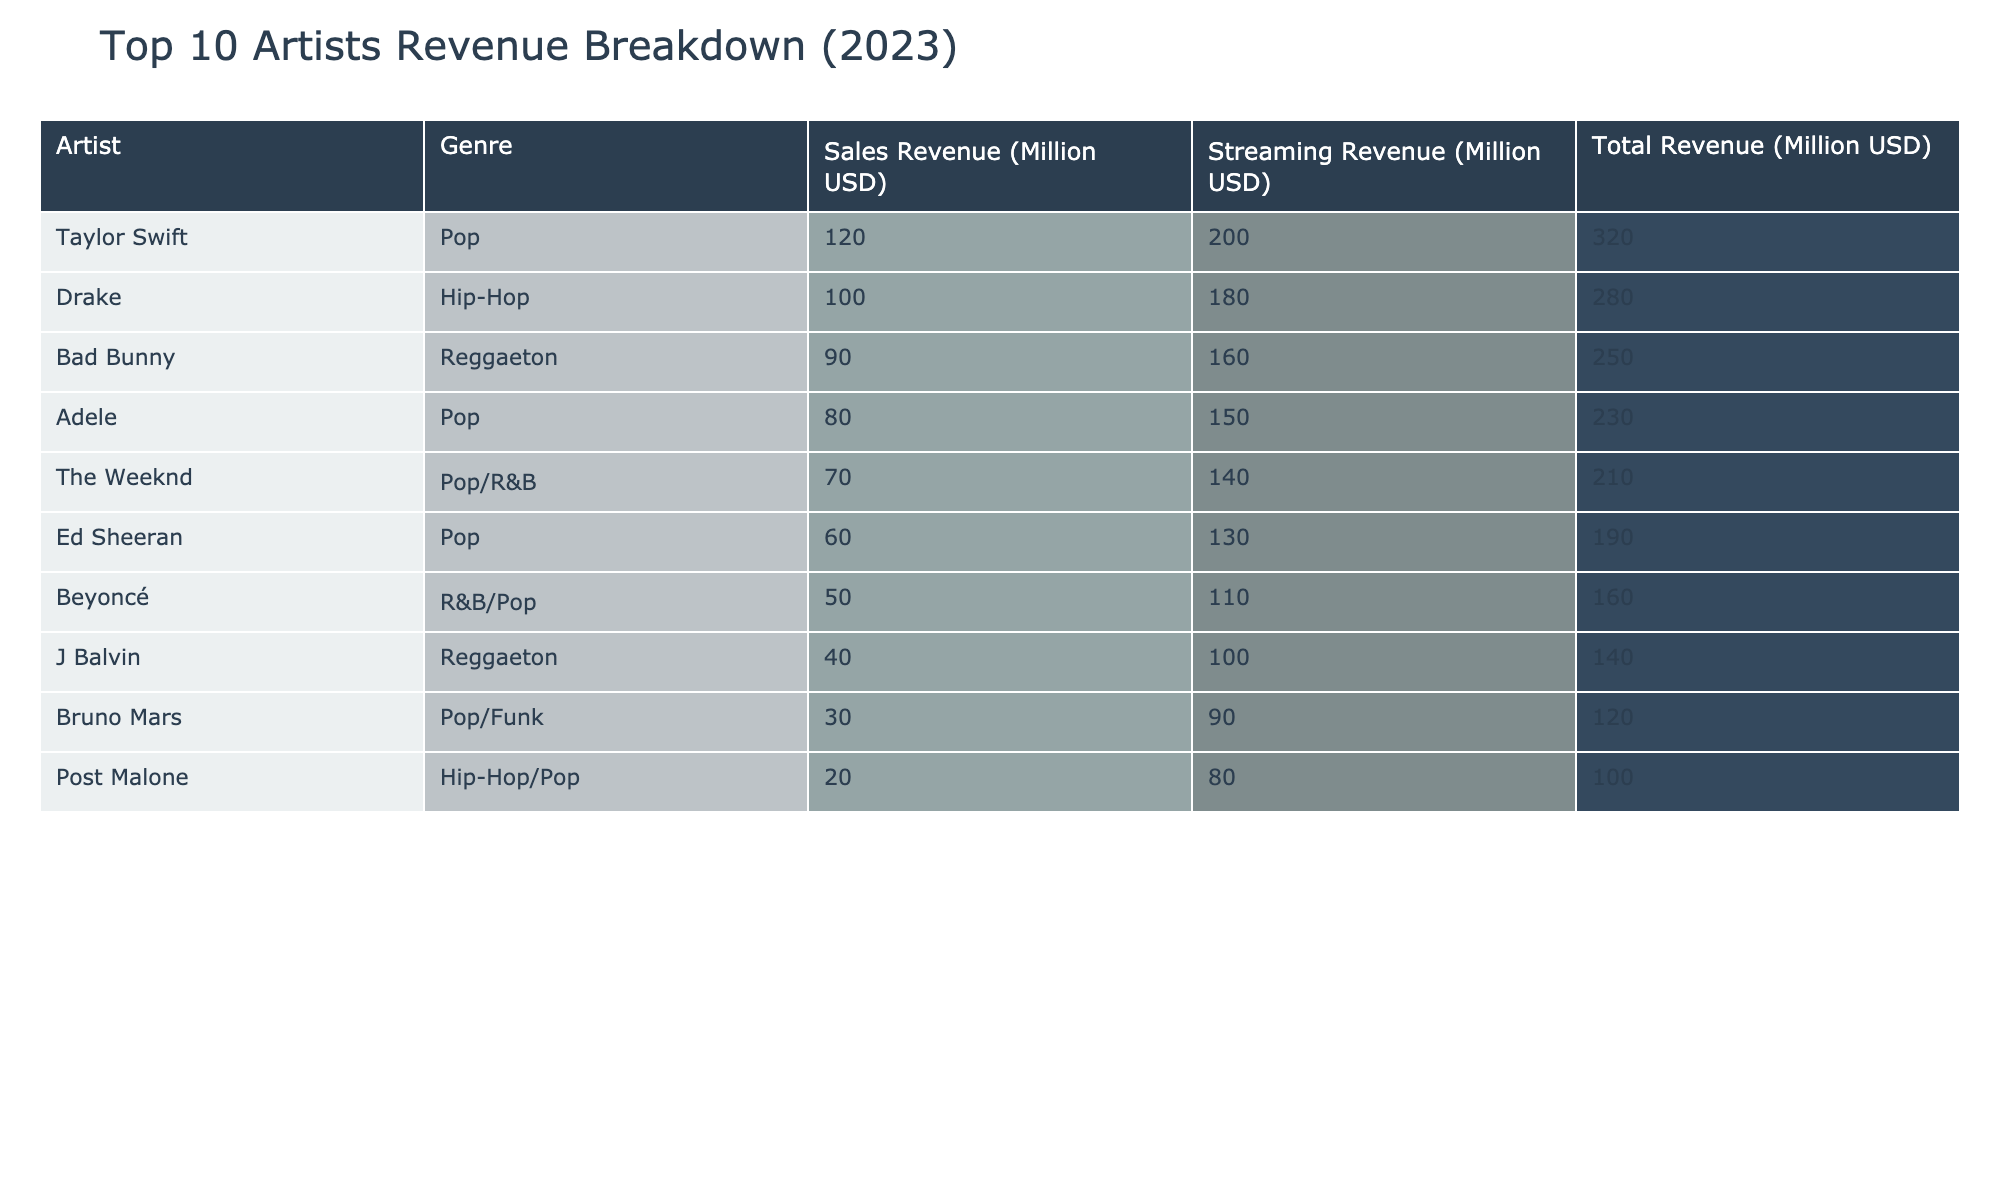What is the total revenue generated by Taylor Swift in 2023? Taylor Swift's total revenue is listed directly in the table as 320 million USD.
Answer: 320 million USD Which artist has the highest streaming revenue? The table indicates that Taylor Swift has the highest streaming revenue at 200 million USD.
Answer: Taylor Swift What is the sales revenue of Adele? The sales revenue for Adele is explicitly shown in the table as 80 million USD.
Answer: 80 million USD How much more streaming revenue does Drake have compared to Bruno Mars? Drake's streaming revenue is 180 million USD, while Bruno Mars has 90 million USD. The difference is 180 - 90 = 90 million USD.
Answer: 90 million USD What is the total revenue for the bottom two artists, Post Malone and Bruno Mars? Post Malone has a total revenue of 100 million USD and Bruno Mars has 120 million USD. Adding these gives 100 + 120 = 220 million USD.
Answer: 220 million USD What percentage of total revenue for Bad Bunny comes from sales revenue? Bad Bunny's total revenue is 250 million USD with 90 million USD from sales. The percentage is (90 / 250) * 100 = 36%.
Answer: 36% Which genre has the highest average sales revenue among the artists listed? The sales figures for Pop artists are: Taylor Swift (120), Adele (80), Ed Sheeran (60), and Bruno Mars (30). Averaging these gives (120 + 80 + 60 + 30) / 4 = 72.5 million USD. R&B/Pop is represented by Beyoncé with 50 million USD, and Hip-Hop includes Drake (100) and Post Malone (20), averaged as (100 + 20) / 2 = 60 million USD. Comparing averages, Pop at 72.5 million is the highest.
Answer: Pop How many artists have total revenues exceeding 200 million USD? From the table, there are three artists with total revenues over 200 million USD: Taylor Swift (320), Drake (280), and Adele (230). Counting these gives a total of three.
Answer: 3 Is there an artist with equal sales and streaming revenue? No artists show equal sales and streaming revenue in the table; all have different values.
Answer: No What artist experiences the smallest difference between sales and streaming revenue? The smallest difference is for Beyoncé, with 50 million in sales and 110 million in streaming. The difference is 110 - 50 = 60 million.
Answer: Beyoncé 